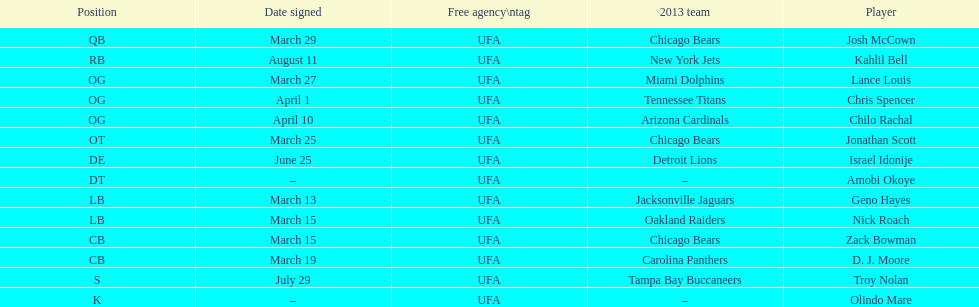How many players play cb or og? 5. 